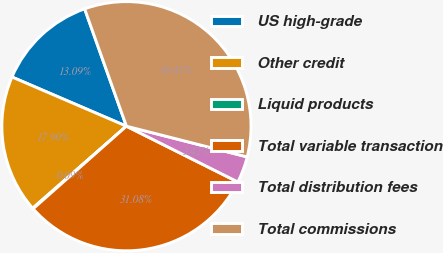<chart> <loc_0><loc_0><loc_500><loc_500><pie_chart><fcel>US high-grade<fcel>Other credit<fcel>Liquid products<fcel>Total variable transaction<fcel>Total distribution fees<fcel>Total commissions<nl><fcel>13.09%<fcel>17.9%<fcel>0.09%<fcel>31.08%<fcel>3.42%<fcel>34.41%<nl></chart> 